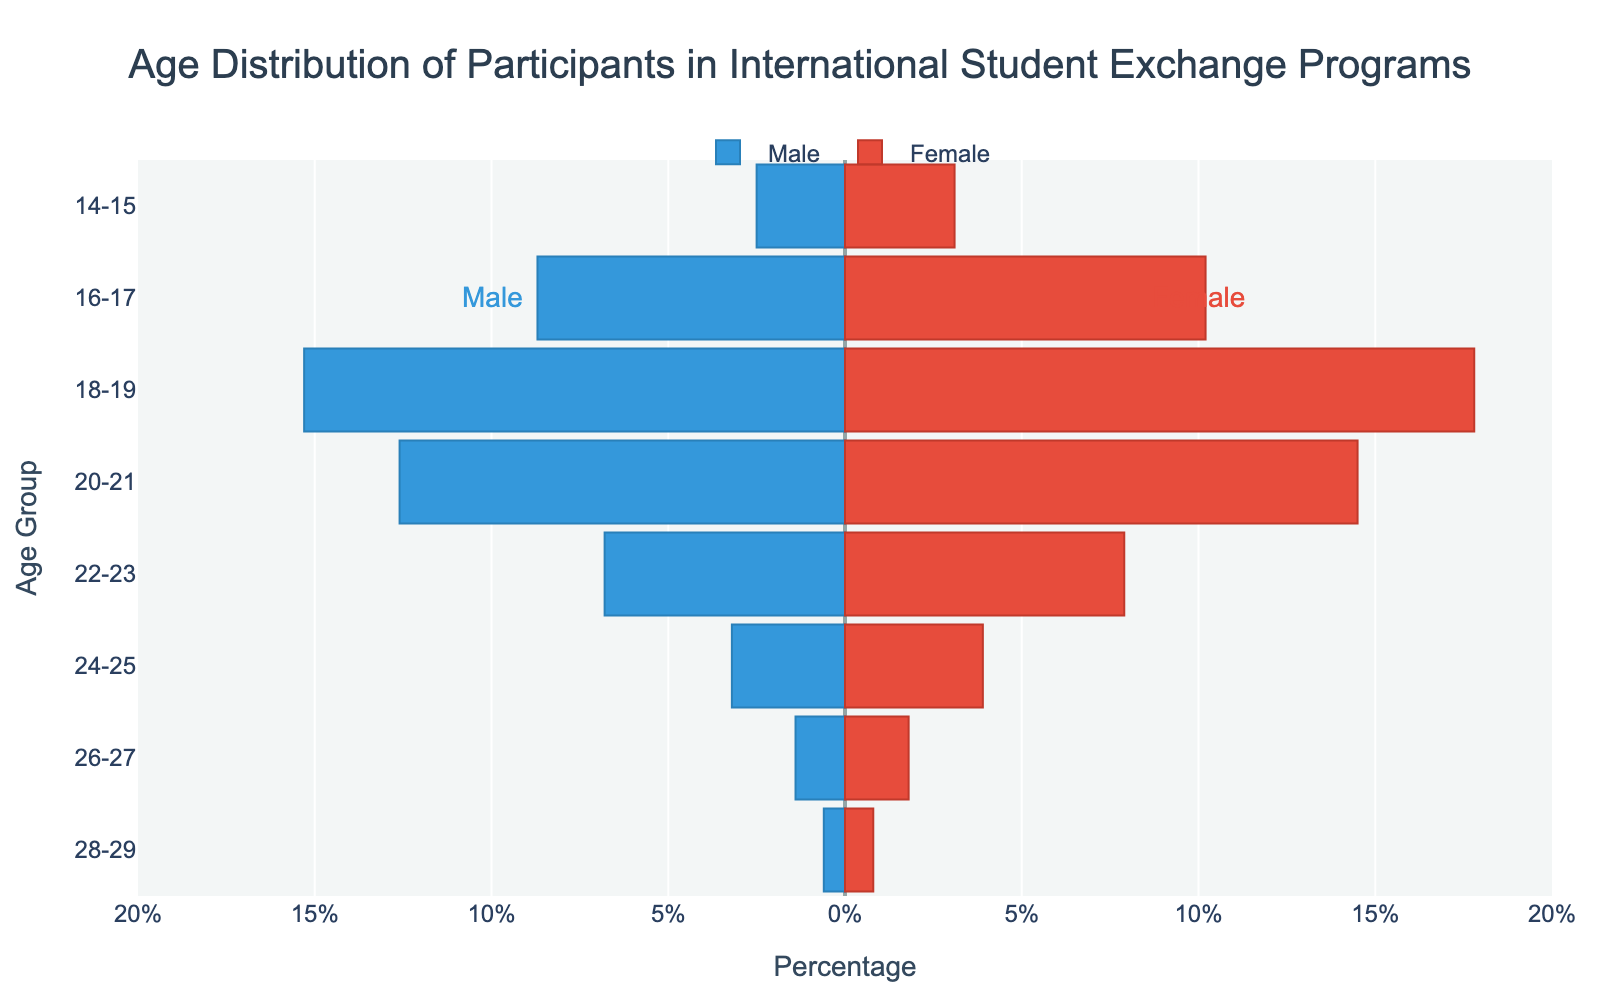what is the age group with the highest percentage of female participants? The highest bar on the female side corresponds to the 18-19 age group with a percentage of 17.8.
Answer: 18-19 What age group has the smallest percentage of male participants? Review the smallest bar on the male side; the smallest percentage is 0.6, corresponding to the 28-29 age group.
Answer: 28-29 Which gender has a higher percentage of participants in the 16-17 age group? Compare the length of the bars for males and females in the 16-17 age group. The female bar is longer with a percentage of 10.2, compared to 8.7 for males.
Answer: Female What is the combined percentage of male participants aged 20-23? Add the percentages of the 20-21 age group (12.6) and the 22-23 age group (6.8): 12.6 + 6.8 = 19.4.
Answer: 19.4 What is the total percentage of participants in the 24-25 age group? Add the male percentage (3.2) and the female percentage (3.9): 3.2 + 3.9 = 7.1.
Answer: 7.1 Which age group has a higher total participant percentage: 20-21 or 22-23? Sum the male and female percentages for each age group: 20-21 (12.6 + 14.5 = 27.1) and 22-23 (6.8 + 7.9 = 14.7). The 20-21 age group has a higher total percentage.
Answer: 20-21 How does the percentage of female participants aged 24-25 compare to the percentage of female participants aged 26-27? Compare the lengths of the female bars for the 24-25 (3.9) and 26-27 (1.8) age groups. The 24-25 age group has a higher percentage.
Answer: 24-25 In which gender and age group is the percentage difference greatest? Calculate the difference for each age group: the largest difference is in the 18-19 age group, where females (17.8) exceed males (15.3) by 2.5.
Answer: Female 18-19 